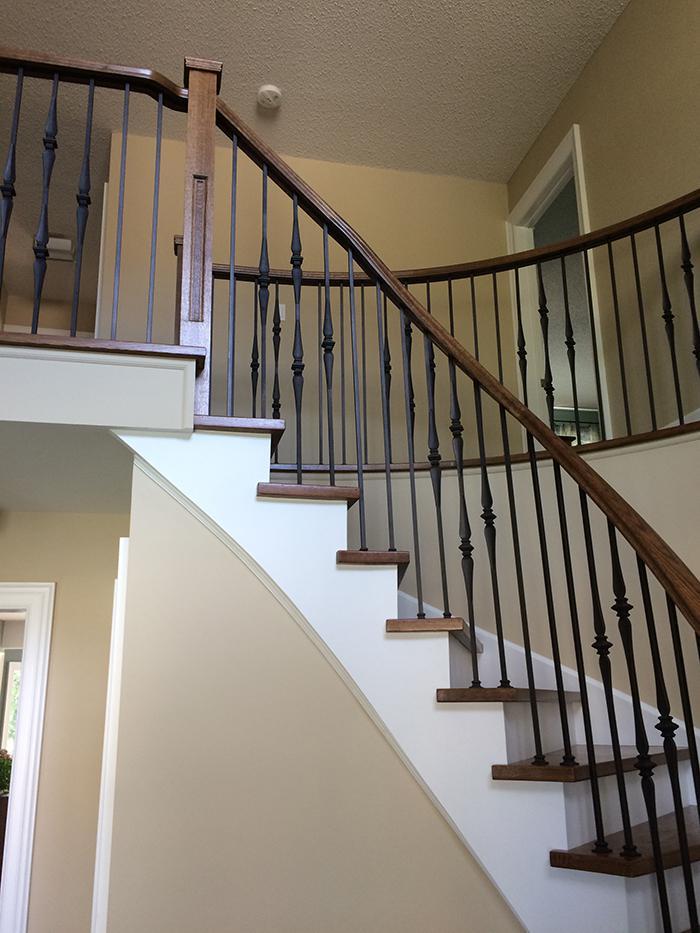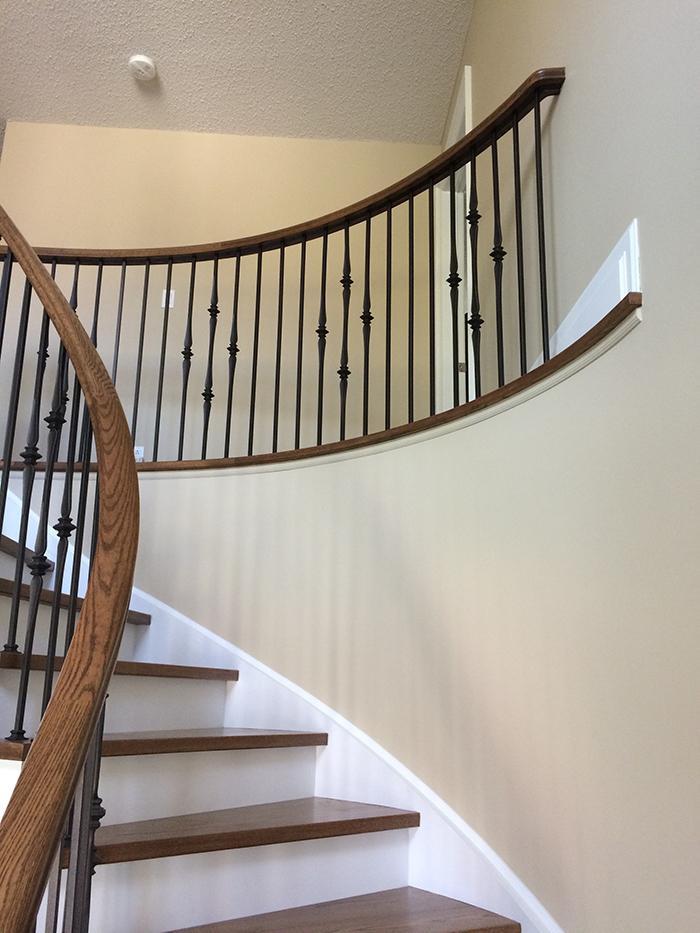The first image is the image on the left, the second image is the image on the right. Analyze the images presented: Is the assertion "there is a wood rail staircase with black iron rods and carpeted stairs" valid? Answer yes or no. No. The first image is the image on the left, the second image is the image on the right. Considering the images on both sides, is "Two staircases and bannisters curve as they go downstairs." valid? Answer yes or no. Yes. 